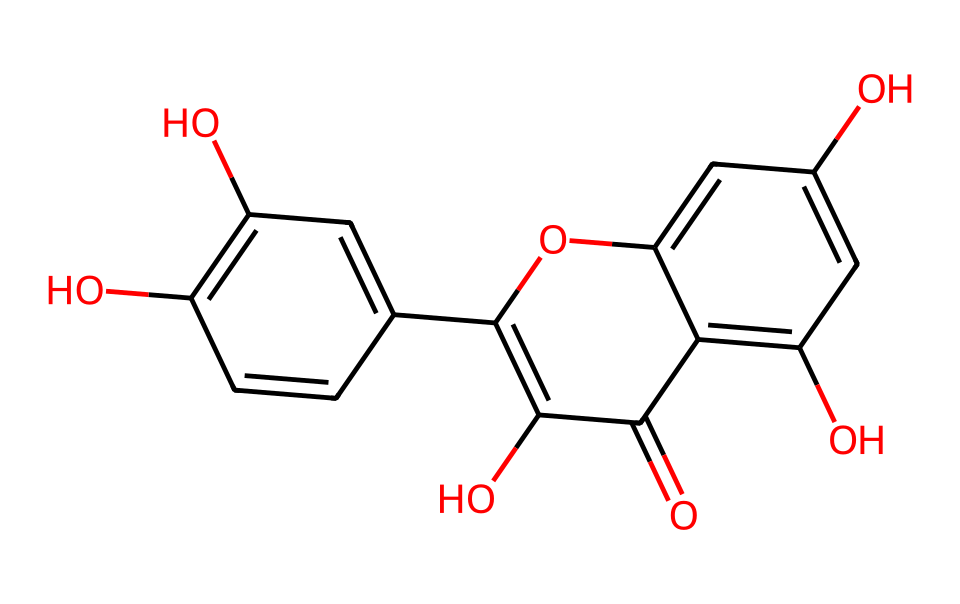What is the name of the chemical represented by the SMILES? The SMILES notation provided corresponds to theaflavins which are a category of polyphenolic compounds found in black tea.
Answer: theaflavins How many carbon atoms are present in the structure? By analyzing the structure in the SMILES, we can count the number of carbon (C) atoms represented. There are a total of 15 carbon atoms in the structure.
Answer: 15 How many hydroxyl (OH) groups are present? The hydroxyl groups can be identified in the SMILES representation where "O" appears in the presence of hydrogen atoms. There are 4 hydroxyl (OH) groups in the structure.
Answer: 4 What is the main functional group present in theaflavins? The aflavins feature phenolic functional groups which can be identified by the presence of adjacent carbon-carbon double bonds and the hydroxyl (OH) groups attached to aromatic rings.
Answer: phenolic Does this chemical contain any ether linkages? Ether linkages are characterized by an oxygen atom connected to two alkyl or aryl groups. The structure of theaflavins does not exhibit such linkages, as it primarily consists of phenol groups and does not have the aforementioned connectivity.
Answer: no What type of rings are present in theaflavins? The structure contains two fused aromatic rings, typically seen in flavonoids. The presence of alternating double bonds characterizes the rings, indicating they are phenolic in nature.
Answer: aromatic rings How is the molecular structure of theaflavins associated with its flavor profile? The presence of multiple hydroxyl groups contributes to the taste profile, enhancing the astringent and bitter flavors characteristic of black tea. This interaction of functional groups with the palate leads to these flavor notes.
Answer: bitter 